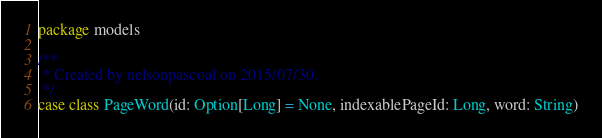Convert code to text. <code><loc_0><loc_0><loc_500><loc_500><_Scala_>package models

/**
 * Created by nelsonpascoal on 2015/07/30.
 */
case class PageWord(id: Option[Long] = None, indexablePageId: Long, word: String)
</code> 